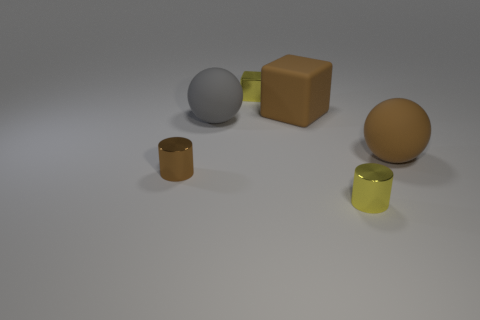Subtract all yellow cylinders. Subtract all gray spheres. How many cylinders are left? 1 Add 1 gray rubber spheres. How many objects exist? 7 Subtract all cylinders. How many objects are left? 4 Add 3 matte balls. How many matte balls are left? 5 Add 5 big brown balls. How many big brown balls exist? 6 Subtract 0 gray blocks. How many objects are left? 6 Subtract all tiny yellow metallic cylinders. Subtract all yellow shiny blocks. How many objects are left? 4 